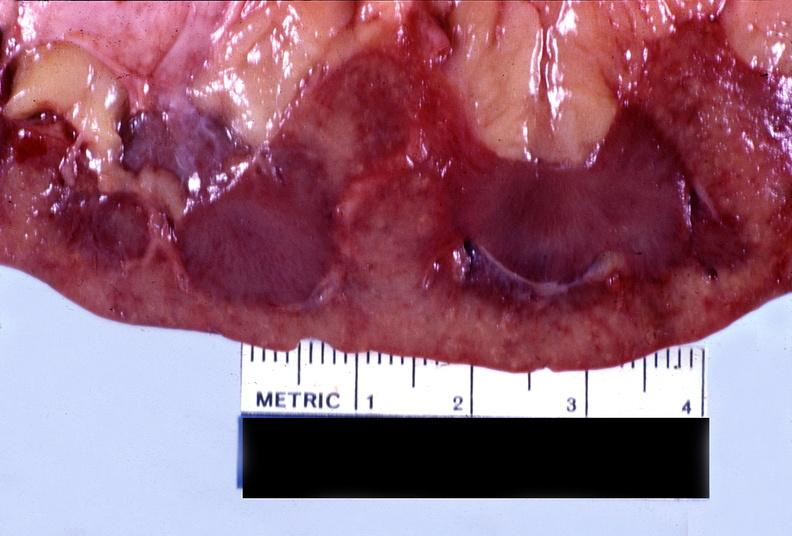does blood show kidney, malignant, nephrosclerosis?
Answer the question using a single word or phrase. No 